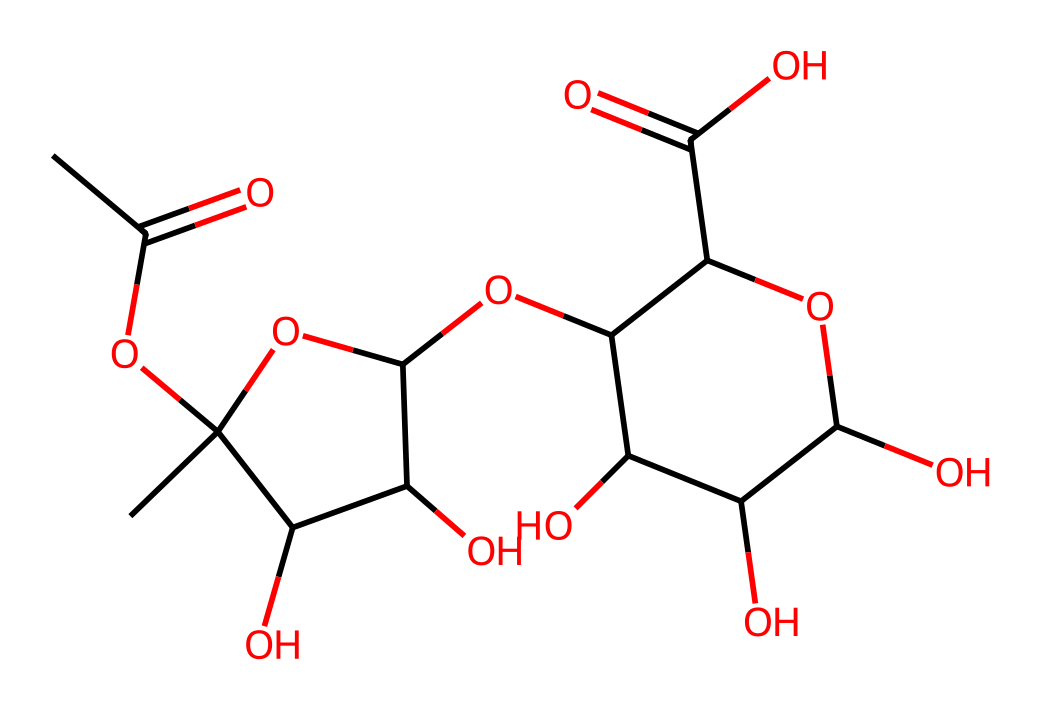What is the molecular weight of pectin based on its structure? To find the molecular weight, we count the number of each type of atom present in the structure provided by the SMILES representation and use the atomic weights for carbon, hydrogen, and oxygen. The calculations show a total molecular weight of 204.2 g/mol.
Answer: 204.2 g/mol How many carbon atoms are present in this carbohydrate? Count the carbon (C) atoms in the structure based on the representation. There are 14 carbon atoms evident in the structure from the SMILES notation.
Answer: 14 What type of glycosidic bonds might be present in pectin? In pectin, glycosidic bonds typically involve the linking of sugar monomers. Analyzing the structure indicates the presence of both alpha (α) and beta (β) glycosidic bonds due to the variation in oxygen and carbon connection arrangements.
Answer: alpha and beta What functional groups are associated with this carbohydrate? By examining the SMILES representation, we identify hydroxyl (-OH) groups, carboxyl (-COOH) groups, and ether linkages (due to the ether bonds between sugar units), which are indicative of pectin's structure.
Answer: hydroxyl, carboxyl, ether How does pectin's structure contribute to its use in eco-friendly smartphone cases? Pectin has a highly branched structure with multiple hydroxyl groups, which can facilitate hydrogen bonding and contribute to its biodegradable properties. This structural characteristic makes it suitable as an eco-friendly material compared to traditional plastics.
Answer: biodegradable properties 